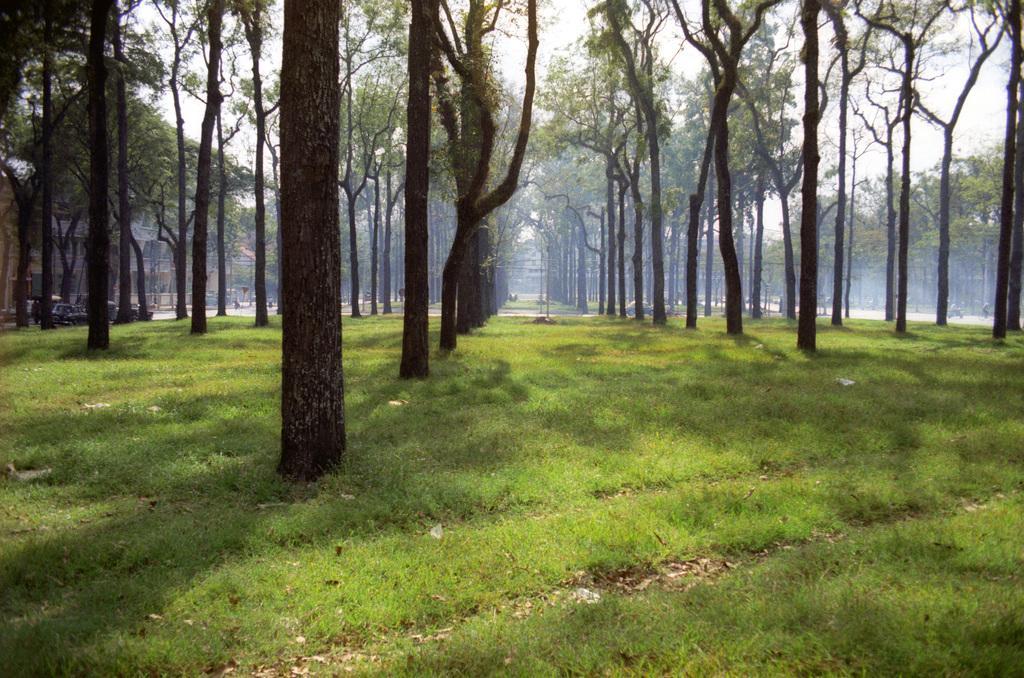Describe this image in one or two sentences. Land is covered with grass. Here we can see trees. Far there are vehicles and building. 